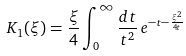<formula> <loc_0><loc_0><loc_500><loc_500>K _ { 1 } ( \xi ) = \frac { \xi } { 4 } \int _ { 0 } ^ { \infty } \frac { d t } { t ^ { 2 } } \, e ^ { - t - \frac { \xi ^ { 2 } } { 4 t } }</formula> 